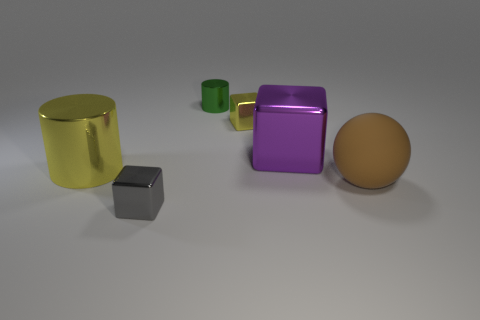Add 3 green cubes. How many objects exist? 9 Subtract all yellow shiny cubes. How many cubes are left? 2 Subtract all cylinders. How many objects are left? 4 Subtract 0 blue cylinders. How many objects are left? 6 Subtract all blue rubber spheres. Subtract all green shiny objects. How many objects are left? 5 Add 2 small shiny cylinders. How many small shiny cylinders are left? 3 Add 3 brown matte blocks. How many brown matte blocks exist? 3 